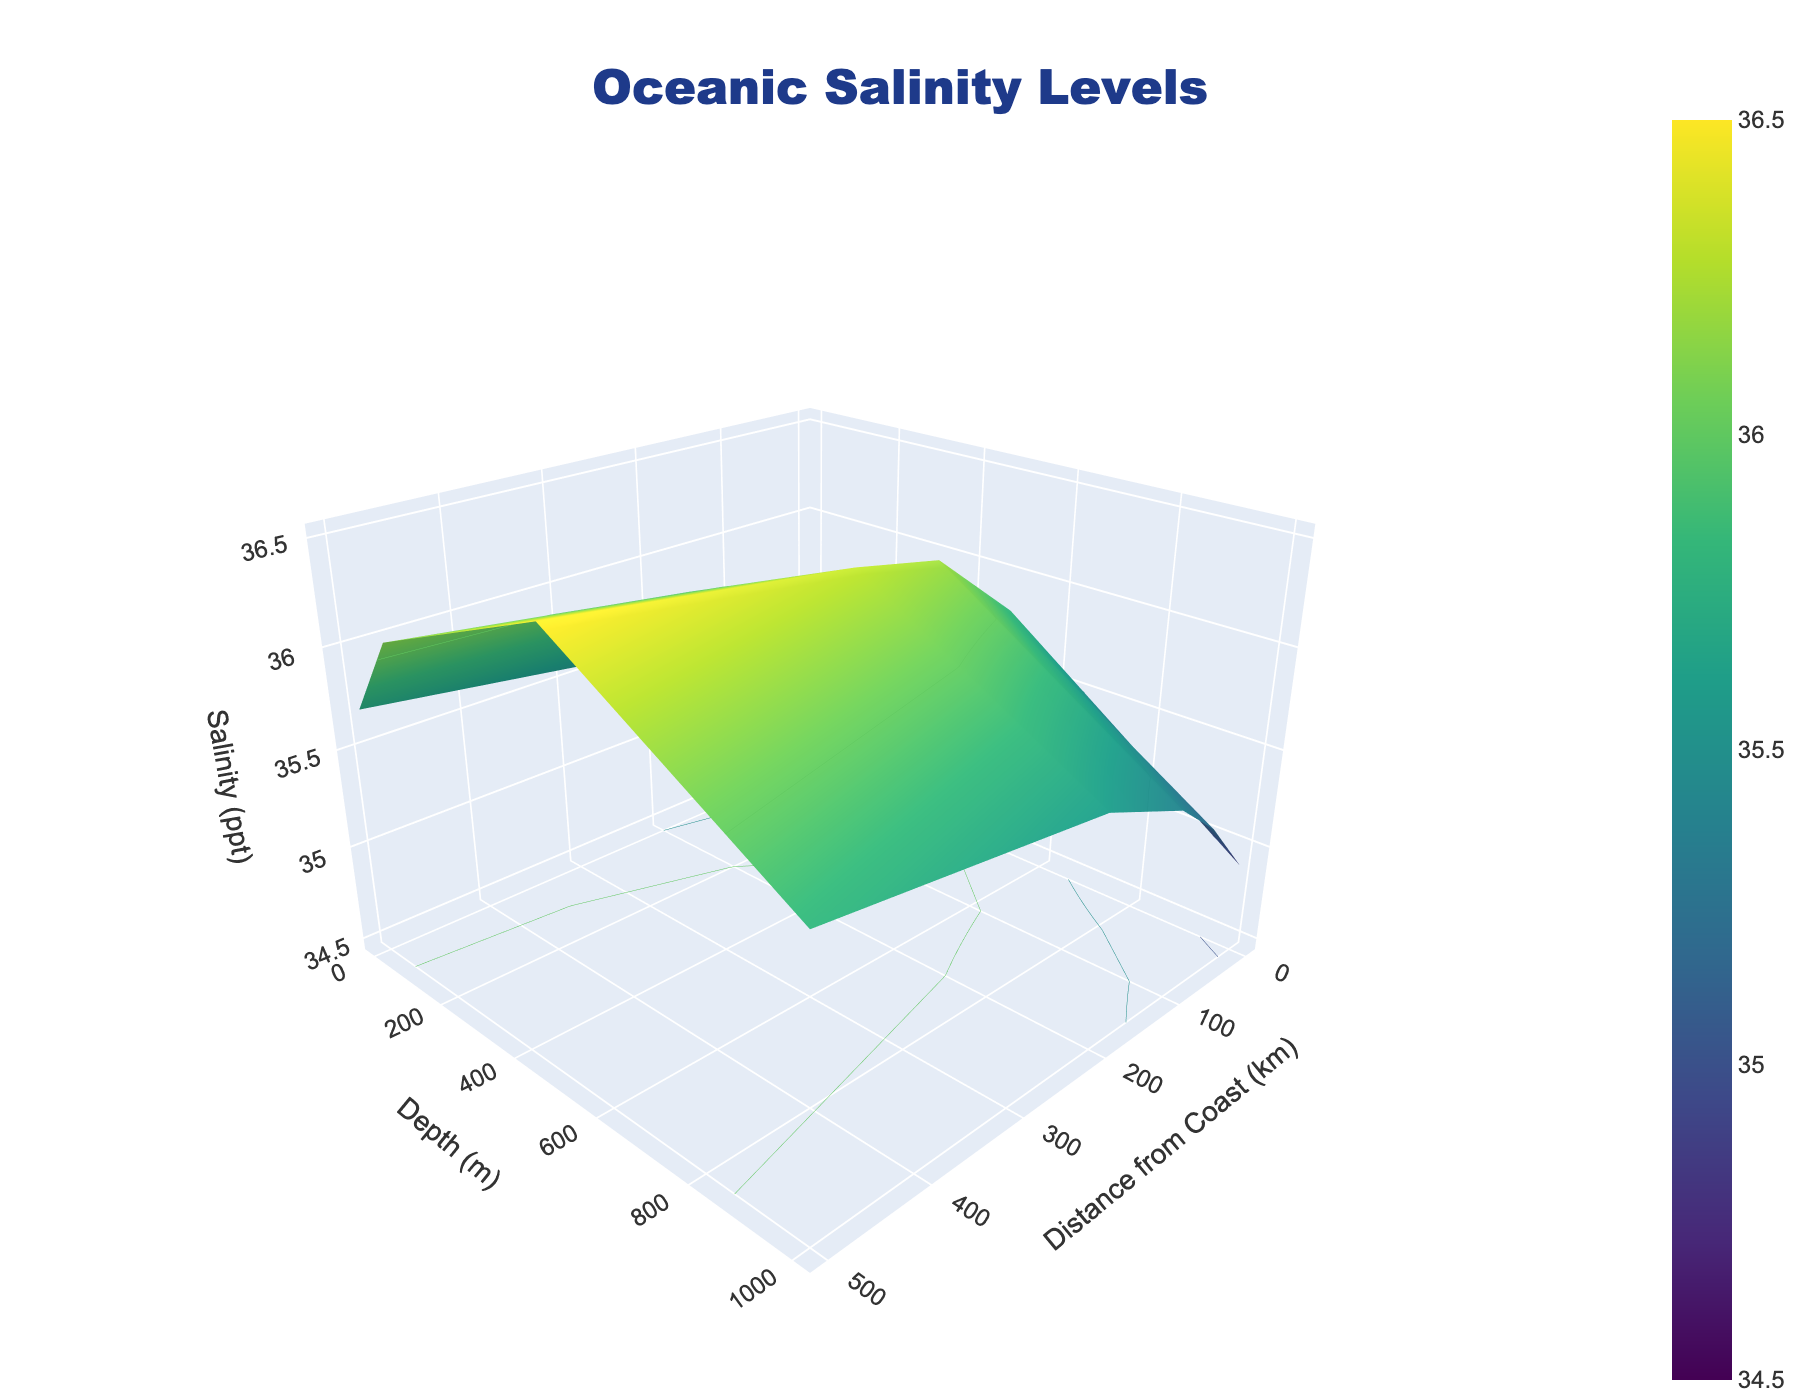what does the title say? The title of the figure is located at the top of the plot and usually indicates what the plot is about.
Answer: Oceanic Salinity Levels what is the range of the 'Distance from Coast' axis? To find the range of an axis, look at the minimum and maximum ticks along that axis.
Answer: 0 to 500 km how does salinity change with increasing depth at 0 km from the coast? Observe the changes in the vertical direction at the position corresponding to 0 km from the coast.
Answer: It increases, then decreases where is the salinity the highest? Identify the peak point on the surface plot which represents the highest value.
Answer: At 500 km from the coast and 500 m depth how does the salinity at 1000 m depth compare between 0 km and 100 km from the coast? Check the salinity values at 1000 m depth for both 0 km and 100 km from the coast, then compare them.
Answer: Salinity is higher at 100 km what colors are used to indicate different salinity levels? Identify the colors in the plot which correspond to salinity levels, usually provided by the color scale.
Answer: Various shades of green and blue which depth had the highest average salinity across all distances? Calculate the average salinity for each depth by summing the salinity values across all distances for each depth and dividing by the number of distances.
Answer: 500 m how does the salinity trend change moving from 0 to 500 km at a constant depth of 100 m? Check the line at 100 m depth and observe how the values change horizontally from 0 to 500 km.
Answer: Generally increasing what is the salinity at 200 km distance and 500 m depth? Locate the point on the plot at 200 km and 500 m depth to find the salinity value.
Answer: 36.3 ppt does salinity vary more with depth or distance from the coast? Compare the variability in the salinity values observed along the depth versus the distance from the coast to understand which one has more variation.
Answer: Varies more with depth 